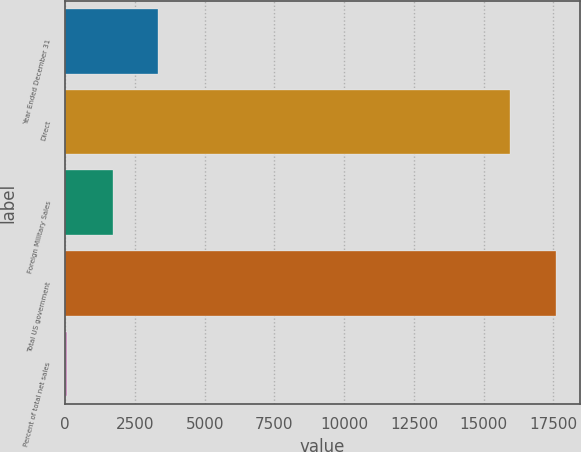Convert chart. <chart><loc_0><loc_0><loc_500><loc_500><bar_chart><fcel>Year Ended December 31<fcel>Direct<fcel>Foreign Military Sales<fcel>Total US government<fcel>Percent of total net sales<nl><fcel>3335.2<fcel>15948<fcel>1701.6<fcel>17581.6<fcel>68<nl></chart> 